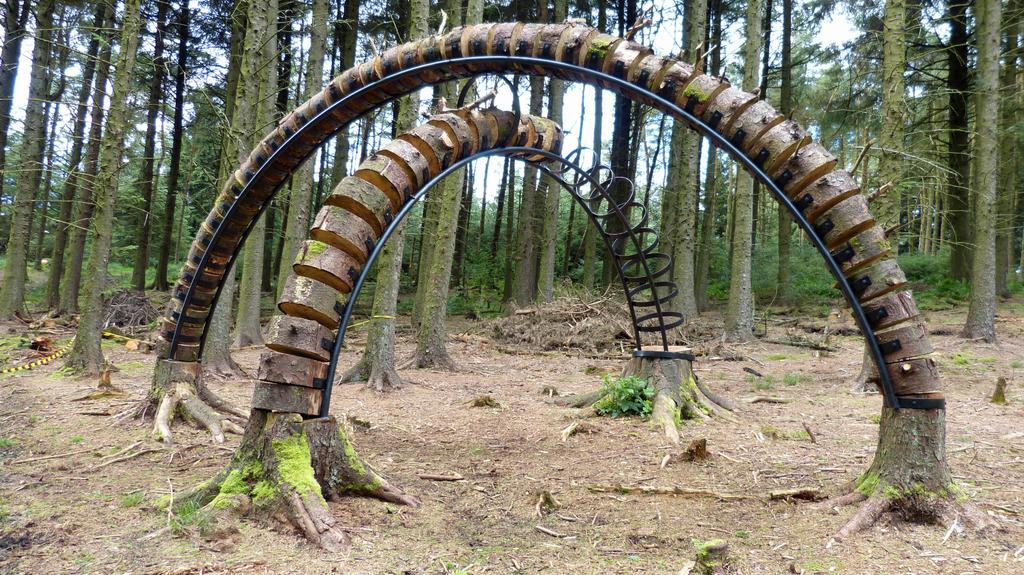What type of natural structure can be seen in the front of the image? There are arches made of trees in the front of the image. What can be observed in the background of the image? There are trees all over the land in the background of the image. How are the trees arranged in the front of the image? The trees are arranged in arches in the front of the image. What might be the purpose of these tree arches? The purpose of the tree arches could be for aesthetic or natural reasons, such as creating a shaded area or a unique landscape feature. How does the mint grow in the image? There is no mint present in the image; it only features arches made of trees in the front and trees all over the land in the background. 